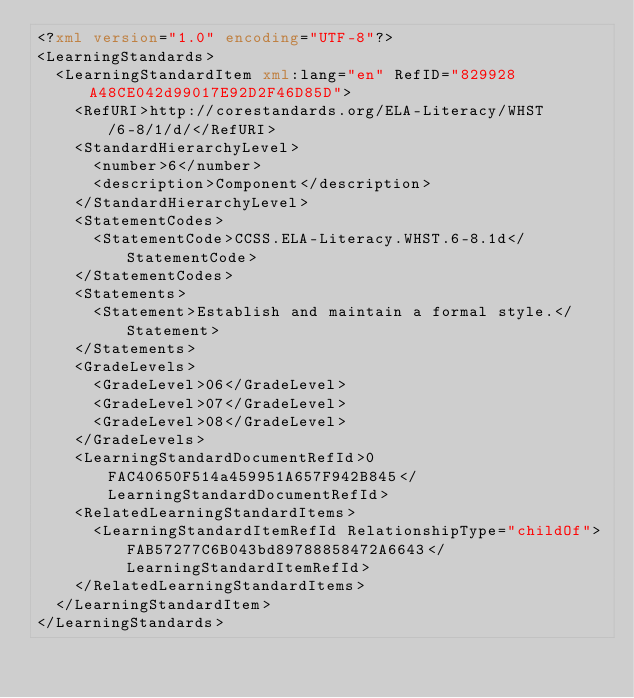<code> <loc_0><loc_0><loc_500><loc_500><_XML_><?xml version="1.0" encoding="UTF-8"?>
<LearningStandards>
  <LearningStandardItem xml:lang="en" RefID="829928A48CE042d99017E92D2F46D85D">
    <RefURI>http://corestandards.org/ELA-Literacy/WHST/6-8/1/d/</RefURI>
    <StandardHierarchyLevel>
      <number>6</number>
      <description>Component</description>
    </StandardHierarchyLevel>
    <StatementCodes>
      <StatementCode>CCSS.ELA-Literacy.WHST.6-8.1d</StatementCode>
    </StatementCodes>
    <Statements>
      <Statement>Establish and maintain a formal style.</Statement>
    </Statements>
    <GradeLevels>
      <GradeLevel>06</GradeLevel>
      <GradeLevel>07</GradeLevel>
      <GradeLevel>08</GradeLevel>
    </GradeLevels>
    <LearningStandardDocumentRefId>0FAC40650F514a459951A657F942B845</LearningStandardDocumentRefId>
    <RelatedLearningStandardItems>
      <LearningStandardItemRefId RelationshipType="childOf">FAB57277C6B043bd89788858472A6643</LearningStandardItemRefId>
    </RelatedLearningStandardItems>
  </LearningStandardItem>
</LearningStandards>
</code> 